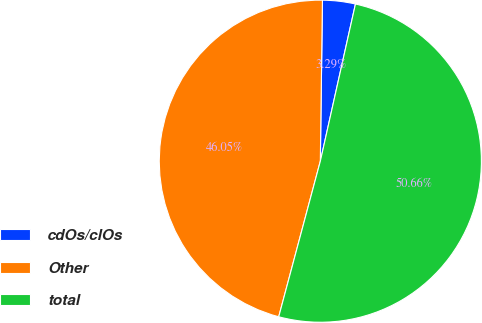<chart> <loc_0><loc_0><loc_500><loc_500><pie_chart><fcel>cdOs/clOs<fcel>Other<fcel>total<nl><fcel>3.29%<fcel>46.05%<fcel>50.66%<nl></chart> 